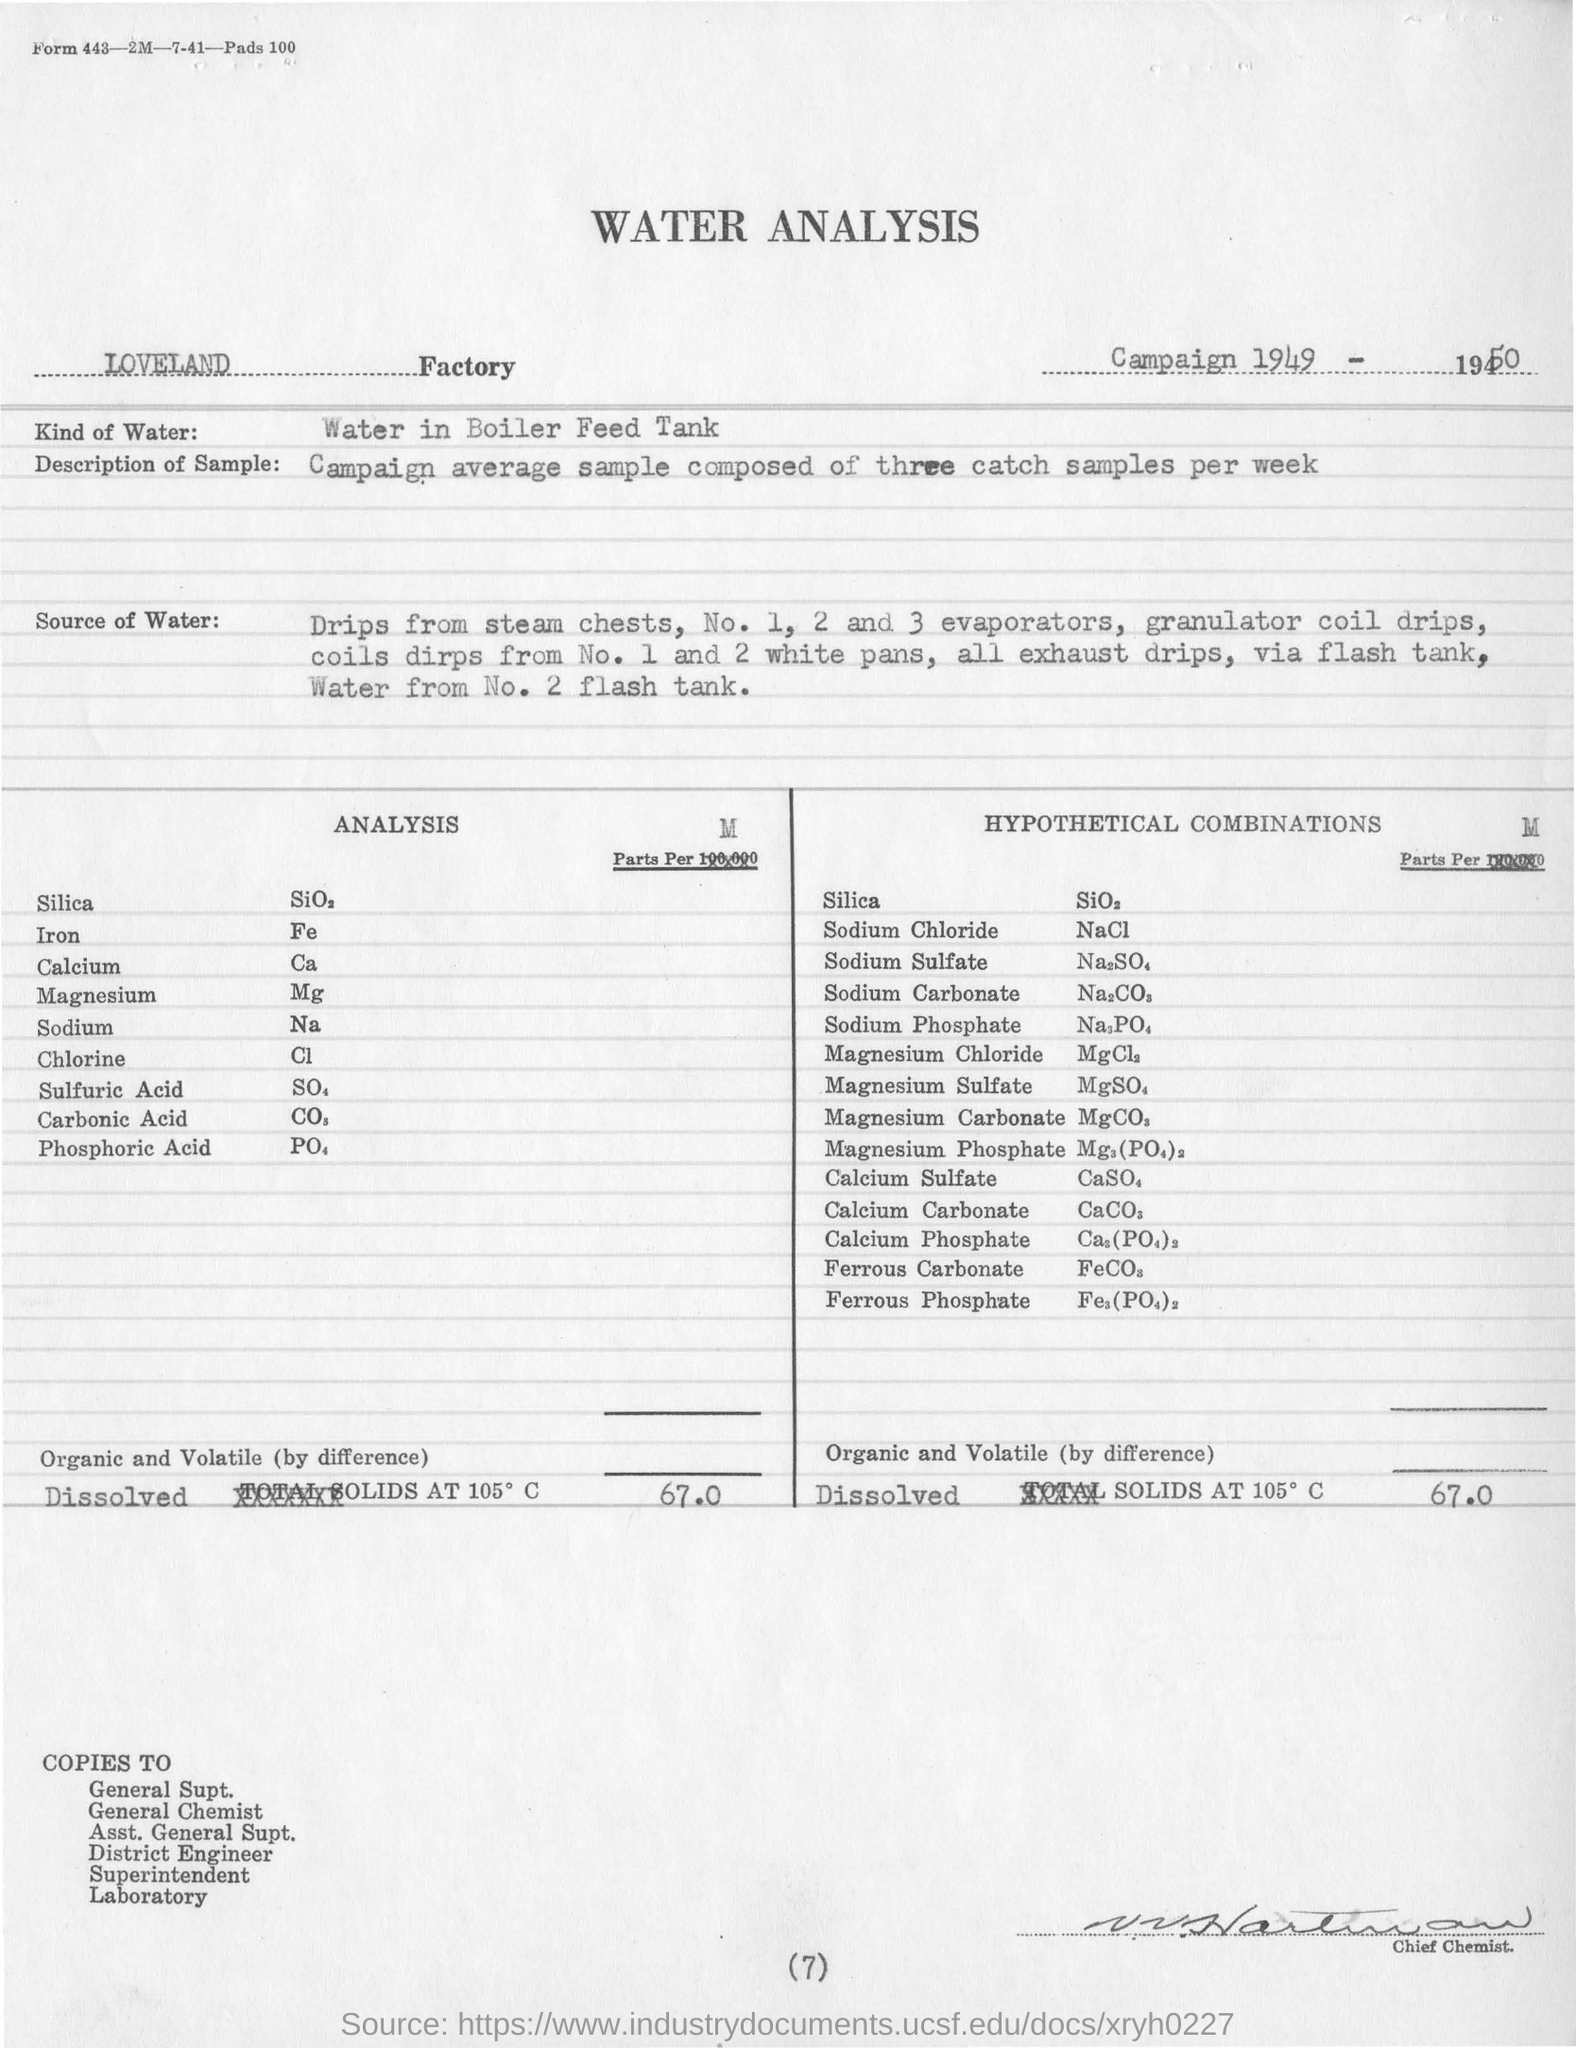Specify some key components in this picture. The main heading mentions the analysis of water. The factory name that was mentioned is "Loveland. The campaign average sample is composed of three catch samples per week. 